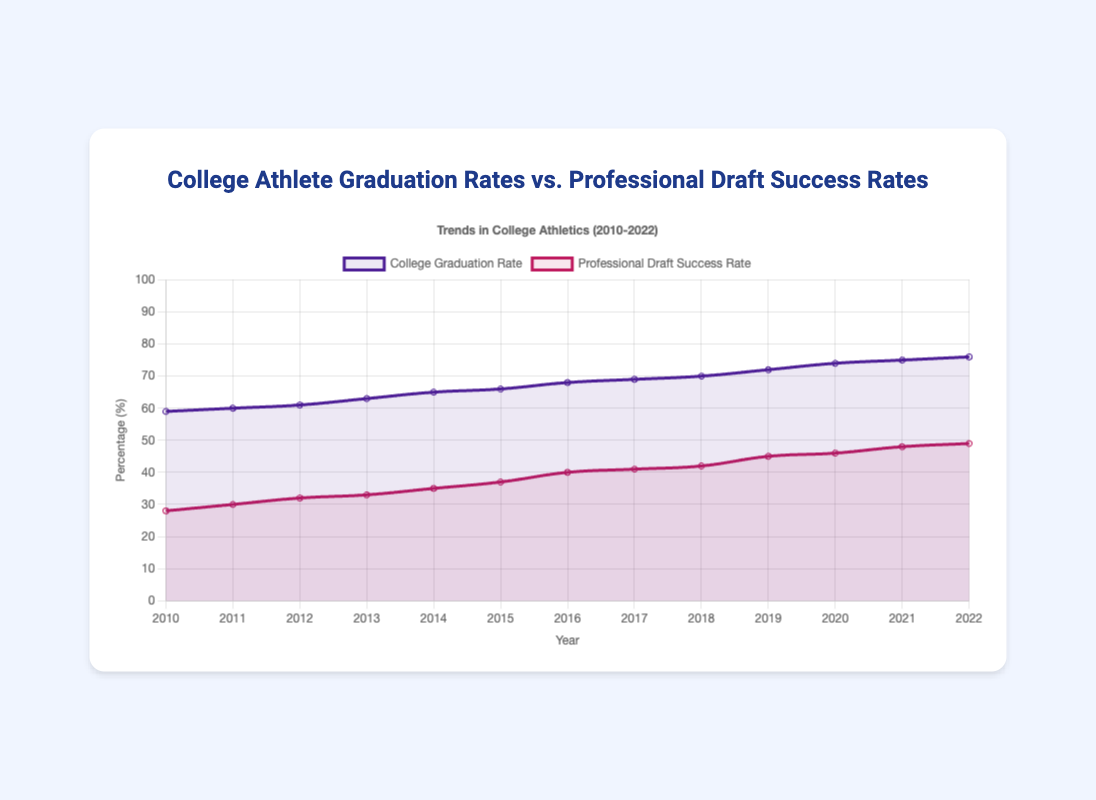What is the overall trend in college graduation rates from 2010 to 2022? The college graduation rates show a general upward trend from 59% in 2010 to 76% in 2022. Each year, the rate either increases or stays the same.
Answer: Upward trend How does the professional draft success rate in 2015 compare to that in 2022? In 2015, the professional draft success rate was 37%, while in 2022 it was 49%. This shows that the draft success rate increased by 12 percentage points from 2015 to 2022.
Answer: Increased by 12 percentage points What is the average college graduation rate over the years 2010 to 2022? The sum of the college graduation rates from 2010 to 2022 is 838. There are 13 years in this range. So, the average rate is 838 / 13 ≈ 64.46%.
Answer: 64.46% Which year had the smallest difference between college graduation rate and professional draft success rate? The smallest difference is seen in 2022 where the difference is 76% - 49% = 27 percentage points.
Answer: 2022 In which year was the professional draft success rate exactly 40%? The professional draft success rate was 40% in the year 2016.
Answer: 2016 Compare the trend of professional draft success rates to that of college graduation rates over the years 2010 to 2022. Both trends show an increase over the years. However, the professional draft success rates increased more gradually and started from a lower base compared to college graduation rates.
Answer: Both increased, professional draft success rates more gradually What visual characteristics differentiate the representation of college graduation rates from professional draft success rates in the chart? The college graduation rates are represented by a purple line with its corresponding area filled lightly, while the professional draft success rates are represented by a red line with a red filled area. The lines and filled colors help to visually separate the two datasets.
Answer: Line and fill color differences How much did the college graduation rate increase from 2010 to 2017? The college graduation rate increased from 59% in 2010 to 69% in 2017. The increase is thus 69% - 59% = 10 percentage points.
Answer: 10 percentage points Which dataset shows a greater overall increment from 2010 to 2022? The professional draft success rate increased from 28% in 2010 to 49% in 2022 (an increase of 21 percentage points), while the college graduation rate increased from 59% in 2010 to 76% in 2022 (an increase of 17 percentage points). Therefore, the professional draft success rate shows a greater increment.
Answer: Professional draft success rate 